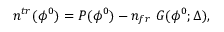<formula> <loc_0><loc_0><loc_500><loc_500>n ^ { t r } ( \phi ^ { 0 } ) = P ( \phi ^ { 0 } ) - n _ { f r } G ( \phi ^ { 0 } ; \Delta ) ,</formula> 